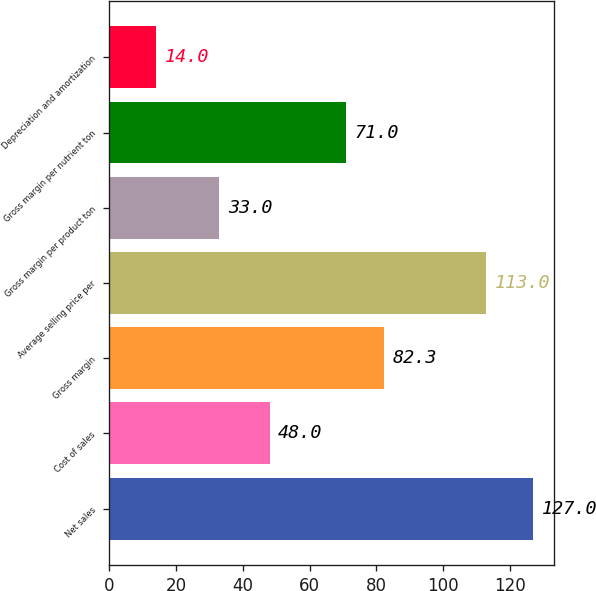Convert chart. <chart><loc_0><loc_0><loc_500><loc_500><bar_chart><fcel>Net sales<fcel>Cost of sales<fcel>Gross margin<fcel>Average selling price per<fcel>Gross margin per product ton<fcel>Gross margin per nutrient ton<fcel>Depreciation and amortization<nl><fcel>127<fcel>48<fcel>82.3<fcel>113<fcel>33<fcel>71<fcel>14<nl></chart> 